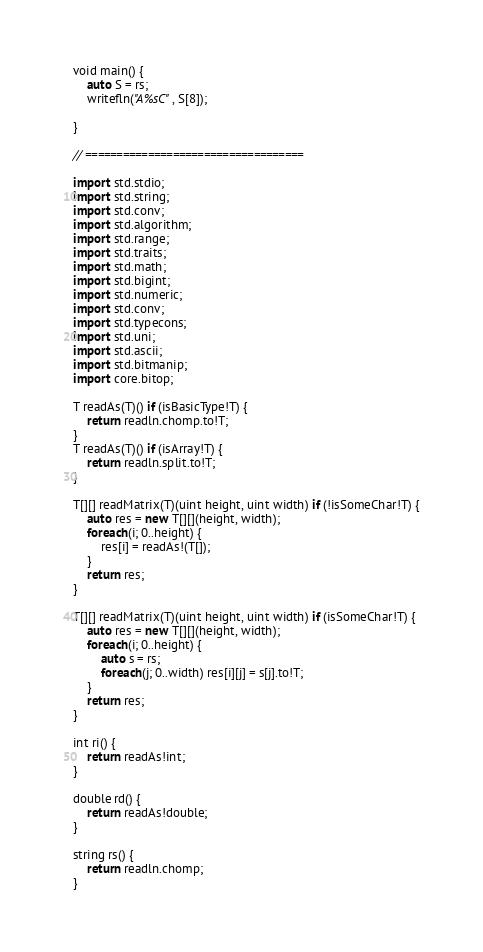Convert code to text. <code><loc_0><loc_0><loc_500><loc_500><_D_>void main() {
	auto S = rs;
	writefln("A%sC", S[8]);
	
}

// ===================================

import std.stdio;
import std.string;
import std.conv;
import std.algorithm;
import std.range;
import std.traits;
import std.math;
import std.bigint;
import std.numeric;
import std.conv;
import std.typecons;
import std.uni;
import std.ascii;
import std.bitmanip;
import core.bitop;

T readAs(T)() if (isBasicType!T) {
	return readln.chomp.to!T;
}
T readAs(T)() if (isArray!T) {
	return readln.split.to!T;
}

T[][] readMatrix(T)(uint height, uint width) if (!isSomeChar!T) {
	auto res = new T[][](height, width);
	foreach(i; 0..height) {
		res[i] = readAs!(T[]);
	}
	return res;
}

T[][] readMatrix(T)(uint height, uint width) if (isSomeChar!T) {
	auto res = new T[][](height, width);
	foreach(i; 0..height) {
		auto s = rs;
		foreach(j; 0..width) res[i][j] = s[j].to!T;
	}
	return res;
}

int ri() {
	return readAs!int;
}

double rd() {
	return readAs!double;
}

string rs() {
	return readln.chomp;
}
</code> 